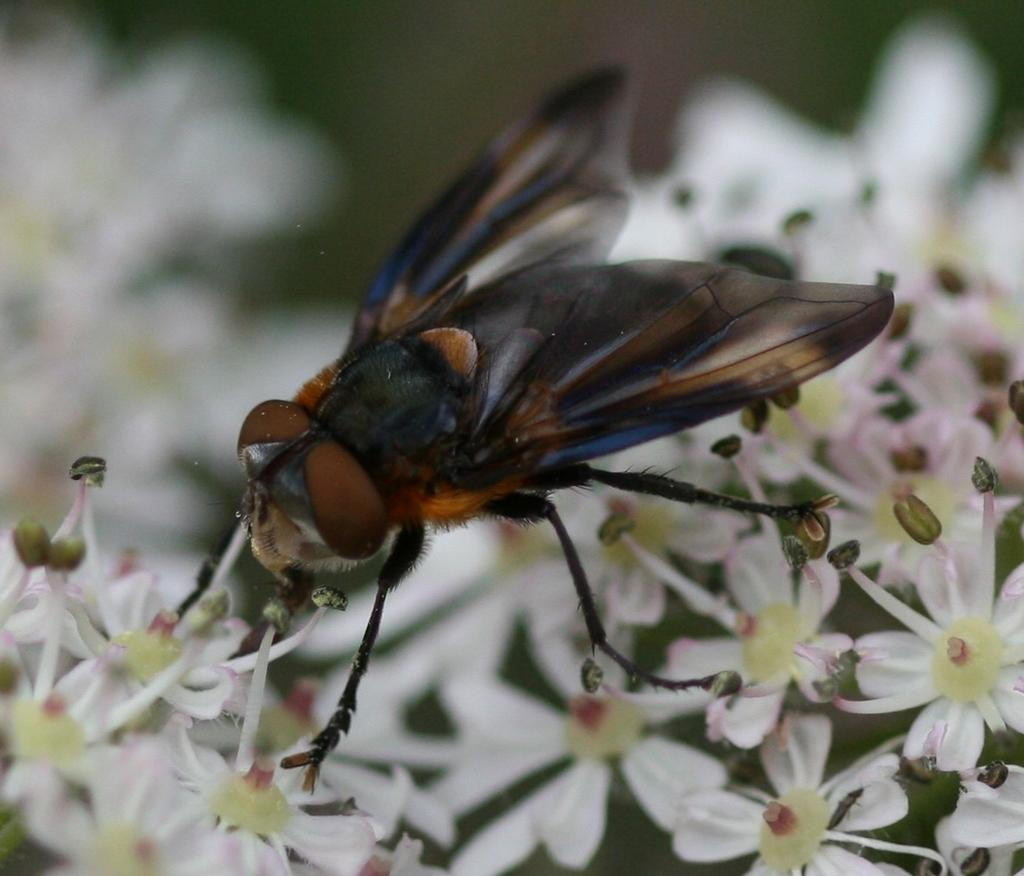What is present in the image? There is a fly in the image. Where is the fly located? The fly is on the flowers. What type of letter is the horse holding in the image? There is no horse or letter present in the image; it only features a fly on the flowers. 